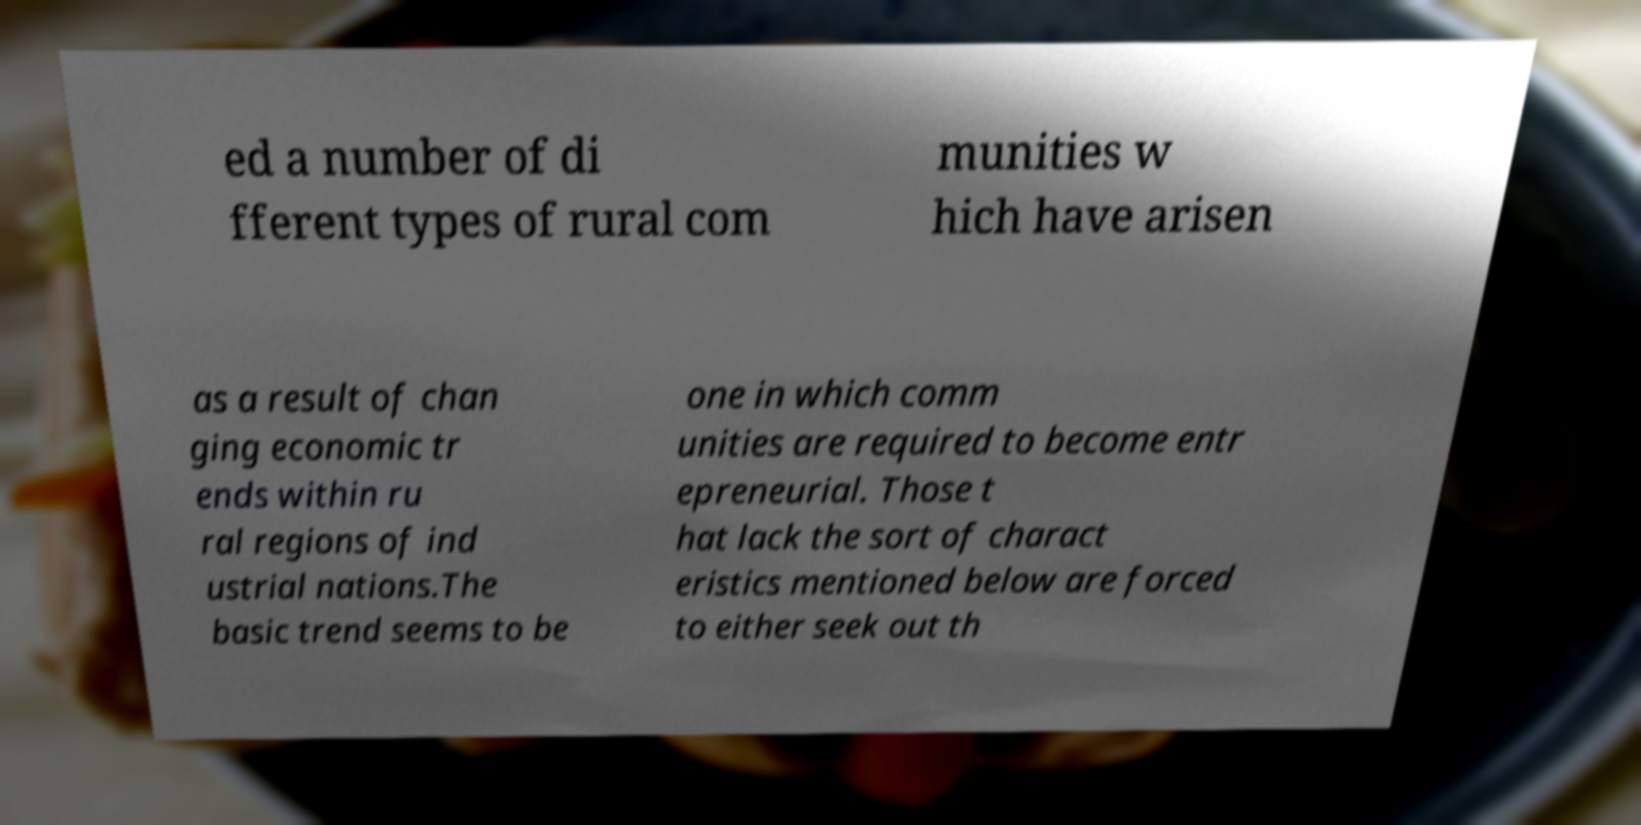I need the written content from this picture converted into text. Can you do that? ed a number of di fferent types of rural com munities w hich have arisen as a result of chan ging economic tr ends within ru ral regions of ind ustrial nations.The basic trend seems to be one in which comm unities are required to become entr epreneurial. Those t hat lack the sort of charact eristics mentioned below are forced to either seek out th 